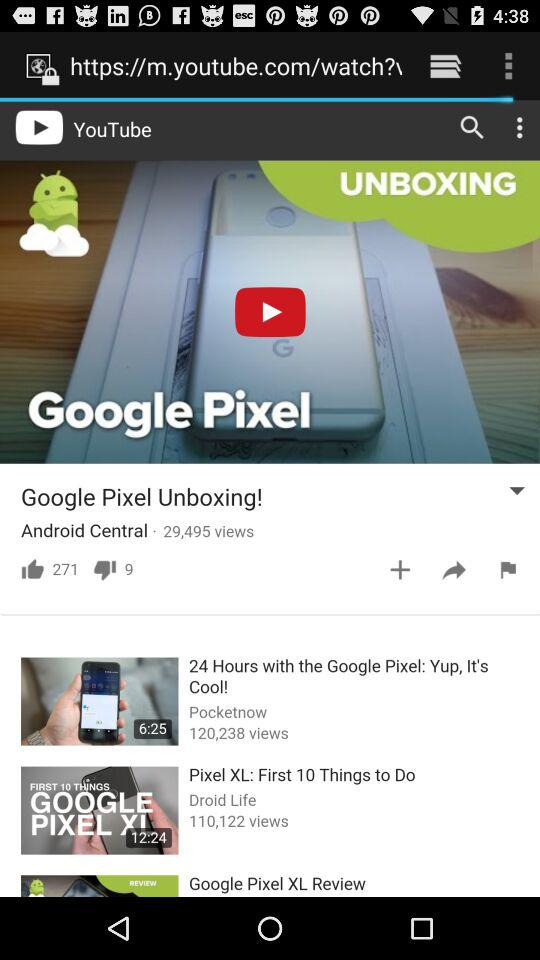What is the count of likes and dislikes on the video? There are 271 likes and 9 dislikes. 